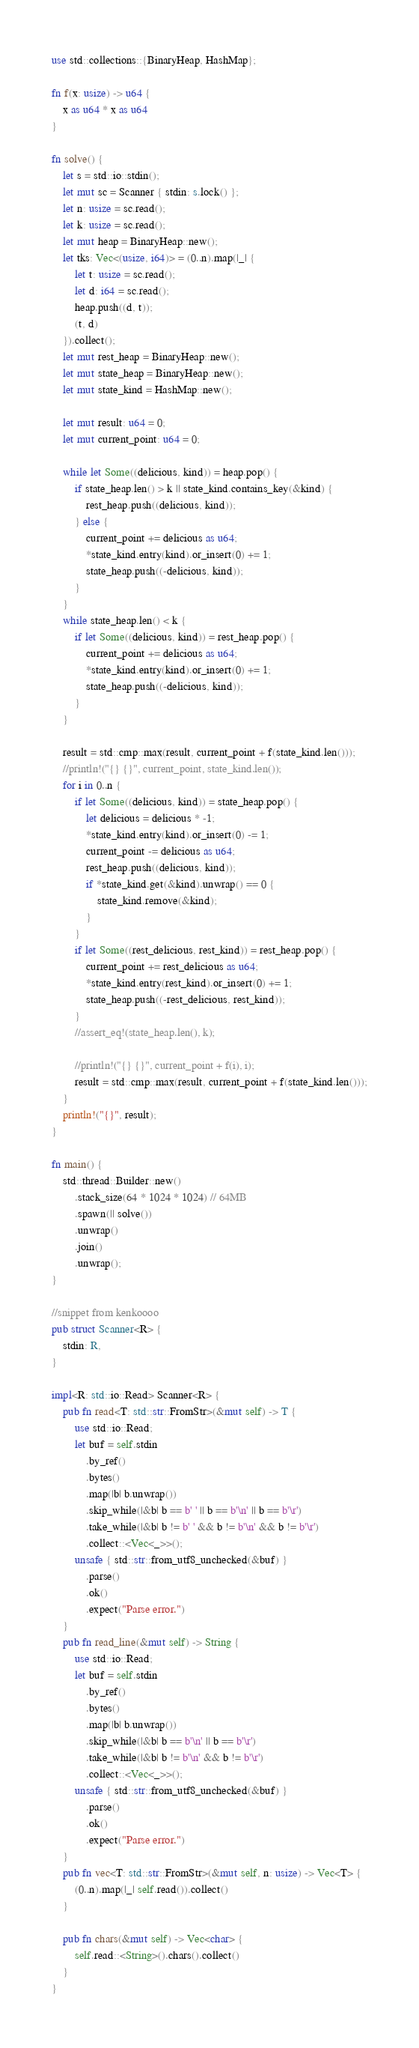<code> <loc_0><loc_0><loc_500><loc_500><_Rust_>use std::collections::{BinaryHeap, HashMap};

fn f(x: usize) -> u64 {
    x as u64 * x as u64
}

fn solve() {
    let s = std::io::stdin();
    let mut sc = Scanner { stdin: s.lock() };
    let n: usize = sc.read();
    let k: usize = sc.read();
    let mut heap = BinaryHeap::new();
    let tks: Vec<(usize, i64)> = (0..n).map(|_| {
        let t: usize = sc.read();
        let d: i64 = sc.read();
        heap.push((d, t));
        (t, d)
    }).collect();
    let mut rest_heap = BinaryHeap::new();
    let mut state_heap = BinaryHeap::new();
    let mut state_kind = HashMap::new();

    let mut result: u64 = 0;
    let mut current_point: u64 = 0;

    while let Some((delicious, kind)) = heap.pop() {
        if state_heap.len() > k || state_kind.contains_key(&kind) {
            rest_heap.push((delicious, kind));
        } else {
            current_point += delicious as u64;
            *state_kind.entry(kind).or_insert(0) += 1;
            state_heap.push((-delicious, kind));
        }
    }
    while state_heap.len() < k {
        if let Some((delicious, kind)) = rest_heap.pop() {
            current_point += delicious as u64;
            *state_kind.entry(kind).or_insert(0) += 1;
            state_heap.push((-delicious, kind));
        }
    }

    result = std::cmp::max(result, current_point + f(state_kind.len()));
    //println!("{} {}", current_point, state_kind.len());
    for i in 0..n {
        if let Some((delicious, kind)) = state_heap.pop() {
            let delicious = delicious * -1;
            *state_kind.entry(kind).or_insert(0) -= 1;
            current_point -= delicious as u64;
            rest_heap.push((delicious, kind));
            if *state_kind.get(&kind).unwrap() == 0 {
                state_kind.remove(&kind);
            }
        }
        if let Some((rest_delicious, rest_kind)) = rest_heap.pop() {
            current_point += rest_delicious as u64;
            *state_kind.entry(rest_kind).or_insert(0) += 1;
            state_heap.push((-rest_delicious, rest_kind));
        }
        //assert_eq!(state_heap.len(), k);

        //println!("{} {}", current_point + f(i), i);
        result = std::cmp::max(result, current_point + f(state_kind.len()));
    }
    println!("{}", result);
}

fn main() {
    std::thread::Builder::new()
        .stack_size(64 * 1024 * 1024) // 64MB
        .spawn(|| solve())
        .unwrap()
        .join()
        .unwrap();
}

//snippet from kenkoooo
pub struct Scanner<R> {
    stdin: R,
}

impl<R: std::io::Read> Scanner<R> {
    pub fn read<T: std::str::FromStr>(&mut self) -> T {
        use std::io::Read;
        let buf = self.stdin
            .by_ref()
            .bytes()
            .map(|b| b.unwrap())
            .skip_while(|&b| b == b' ' || b == b'\n' || b == b'\r')
            .take_while(|&b| b != b' ' && b != b'\n' && b != b'\r')
            .collect::<Vec<_>>();
        unsafe { std::str::from_utf8_unchecked(&buf) }
            .parse()
            .ok()
            .expect("Parse error.")
    }
    pub fn read_line(&mut self) -> String {
        use std::io::Read;
        let buf = self.stdin
            .by_ref()
            .bytes()
            .map(|b| b.unwrap())
            .skip_while(|&b| b == b'\n' || b == b'\r')
            .take_while(|&b| b != b'\n' && b != b'\r')
            .collect::<Vec<_>>();
        unsafe { std::str::from_utf8_unchecked(&buf) }
            .parse()
            .ok()
            .expect("Parse error.")
    }
    pub fn vec<T: std::str::FromStr>(&mut self, n: usize) -> Vec<T> {
        (0..n).map(|_| self.read()).collect()
    }

    pub fn chars(&mut self) -> Vec<char> {
        self.read::<String>().chars().collect()
    }
}
</code> 